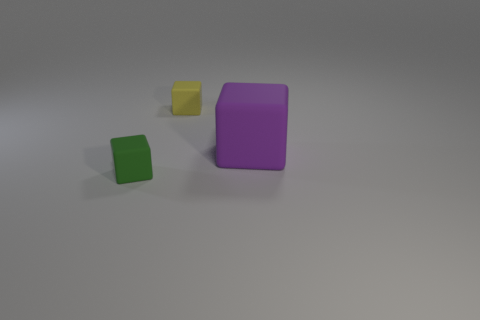Can you tell me what material the objects might be made of based on their appearance? Based on the matte surface and the soft edges, the objects could be made of a plastic or rubber-like material, which is commonly used for toys or decorative items. 